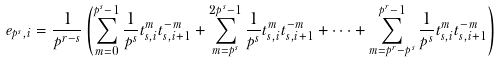Convert formula to latex. <formula><loc_0><loc_0><loc_500><loc_500>e _ { p ^ { s } , i } = \frac { 1 } { p ^ { r - s } } \left ( \sum _ { m = 0 } ^ { p ^ { s } - 1 } \frac { 1 } { p ^ { s } } t _ { s , i } ^ { m } t _ { s , i + 1 } ^ { - m } + \sum _ { m = p ^ { s } } ^ { 2 p ^ { s } - 1 } \frac { 1 } { p ^ { s } } t _ { s , i } ^ { m } t _ { s , i + 1 } ^ { - m } + \cdots + \sum _ { m = p ^ { r } - p ^ { s } } ^ { p ^ { r } - 1 } \frac { 1 } { p ^ { s } } t _ { s , i } ^ { m } t _ { s , i + 1 } ^ { - m } \right )</formula> 